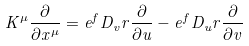<formula> <loc_0><loc_0><loc_500><loc_500>K ^ { \mu } \frac { \partial } { \partial x ^ { \mu } } = e ^ { f } D _ { v } r \frac { \partial } { \partial u } - e ^ { f } D _ { u } r \frac { \partial } { \partial v }</formula> 